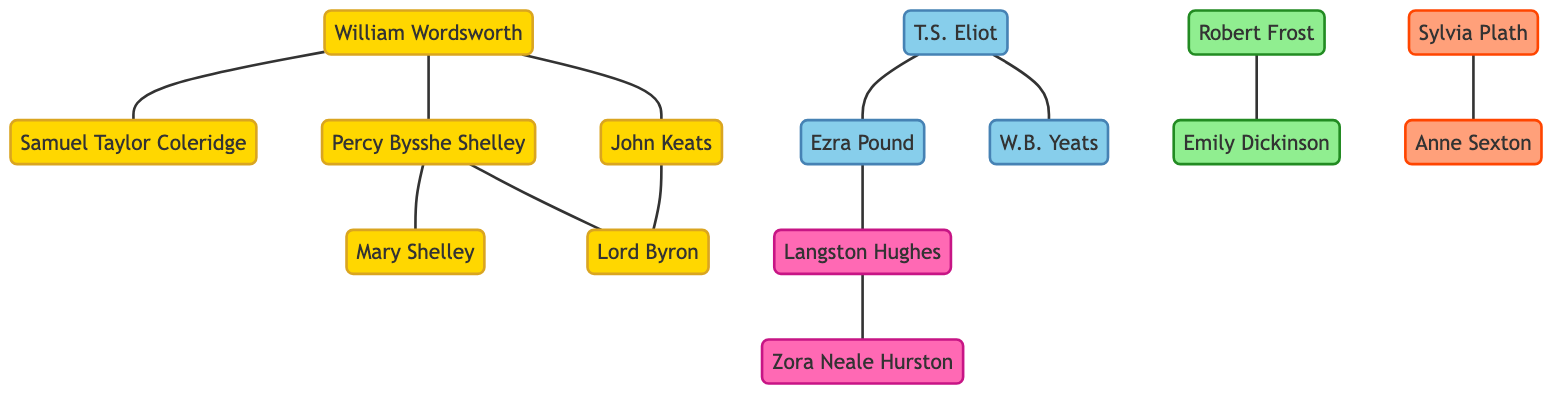What is the total number of poets and literary figures in the diagram? To find the total number of poets and literary figures, we count the number of unique nodes in the provided data. There are 14 individual nodes listed under "nodes." Thus, the total number is 14.
Answer: 14 Which poet is inspired by William Wordsworth? We look at the links originating from William Wordsworth. The nodes connected to him and marked as "inspired" include John Keats and Percy Bysshe Shelley. Therefore, one poet inspired by William Wordsworth is John Keats.
Answer: John Keats How many edges connect to Percy Bysshe Shelley? By reviewing the links related to Percy Bysshe Shelley, we identify that he has three connections to other nodes: to Mary Shelley (spouse), Lord Byron (friend), and William Wordsworth (inspired). Thus, the total number of edges connected to him is 3.
Answer: 3 Who is the mentor of T.S. Eliot? Looking at the connections related to T.S. Eliot, we find a link indicating that Ezra Pound acts as his mentor. Thus, the answer is Ezra Pound.
Answer: Ezra Pound In which literary group is Emily Dickinson classified? Referring to the categorization in the "nodes," Emily Dickinson is grouped under "American Poets." So, the answer is American Poets.
Answer: American Poets What type of relationship exists between Langston Hughes and Zora Neale Hurston? Checking the relationship between Langston Hughes and Zora Neale Hurston, we see that the link states they are friends. Therefore, the type of relationship is friendship.
Answer: friend How many Romantic Poets are connected to Lord Byron? We analyze the edges linked to Lord Byron. He has connections to Percy Bysshe Shelley (friend) and John Keats (contemporary), in addition to being in the same group as the other Romantic Poets. Thus, counting these, he is directly connected to 2 Romantic Poets.
Answer: 2 Which literary figure inspired T.S. Eliot? Upon reviewing the links connected to T.S. Eliot, we identify that W.B. Yeats is mentioned as being inspired by him. Therefore, the answer is W.B. Yeats.
Answer: W.B. Yeats What is the connection type between Robert Frost and Emily Dickinson? By examining the relationship links involving Robert Frost, we find that he admires Emily Dickinson, indicating the type of connection is admiration.
Answer: admired 